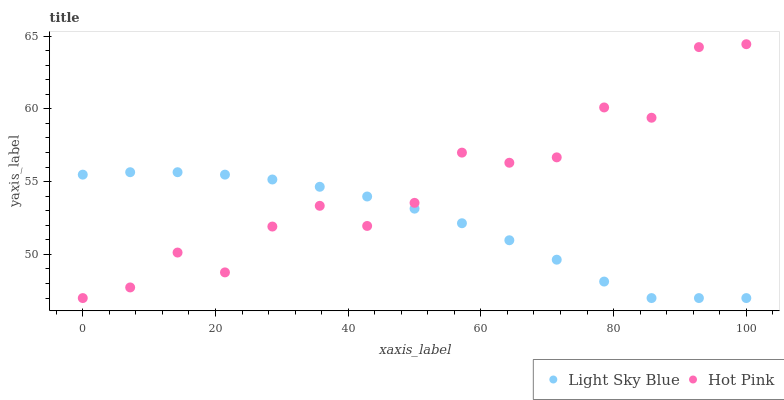Does Light Sky Blue have the minimum area under the curve?
Answer yes or no. Yes. Does Hot Pink have the maximum area under the curve?
Answer yes or no. Yes. Does Hot Pink have the minimum area under the curve?
Answer yes or no. No. Is Light Sky Blue the smoothest?
Answer yes or no. Yes. Is Hot Pink the roughest?
Answer yes or no. Yes. Is Hot Pink the smoothest?
Answer yes or no. No. Does Light Sky Blue have the lowest value?
Answer yes or no. Yes. Does Hot Pink have the highest value?
Answer yes or no. Yes. Does Hot Pink intersect Light Sky Blue?
Answer yes or no. Yes. Is Hot Pink less than Light Sky Blue?
Answer yes or no. No. Is Hot Pink greater than Light Sky Blue?
Answer yes or no. No. 